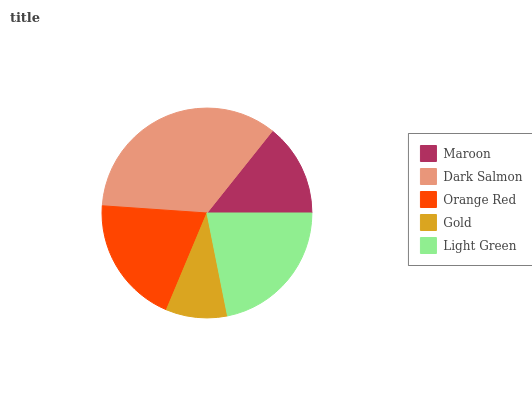Is Gold the minimum?
Answer yes or no. Yes. Is Dark Salmon the maximum?
Answer yes or no. Yes. Is Orange Red the minimum?
Answer yes or no. No. Is Orange Red the maximum?
Answer yes or no. No. Is Dark Salmon greater than Orange Red?
Answer yes or no. Yes. Is Orange Red less than Dark Salmon?
Answer yes or no. Yes. Is Orange Red greater than Dark Salmon?
Answer yes or no. No. Is Dark Salmon less than Orange Red?
Answer yes or no. No. Is Orange Red the high median?
Answer yes or no. Yes. Is Orange Red the low median?
Answer yes or no. Yes. Is Dark Salmon the high median?
Answer yes or no. No. Is Dark Salmon the low median?
Answer yes or no. No. 